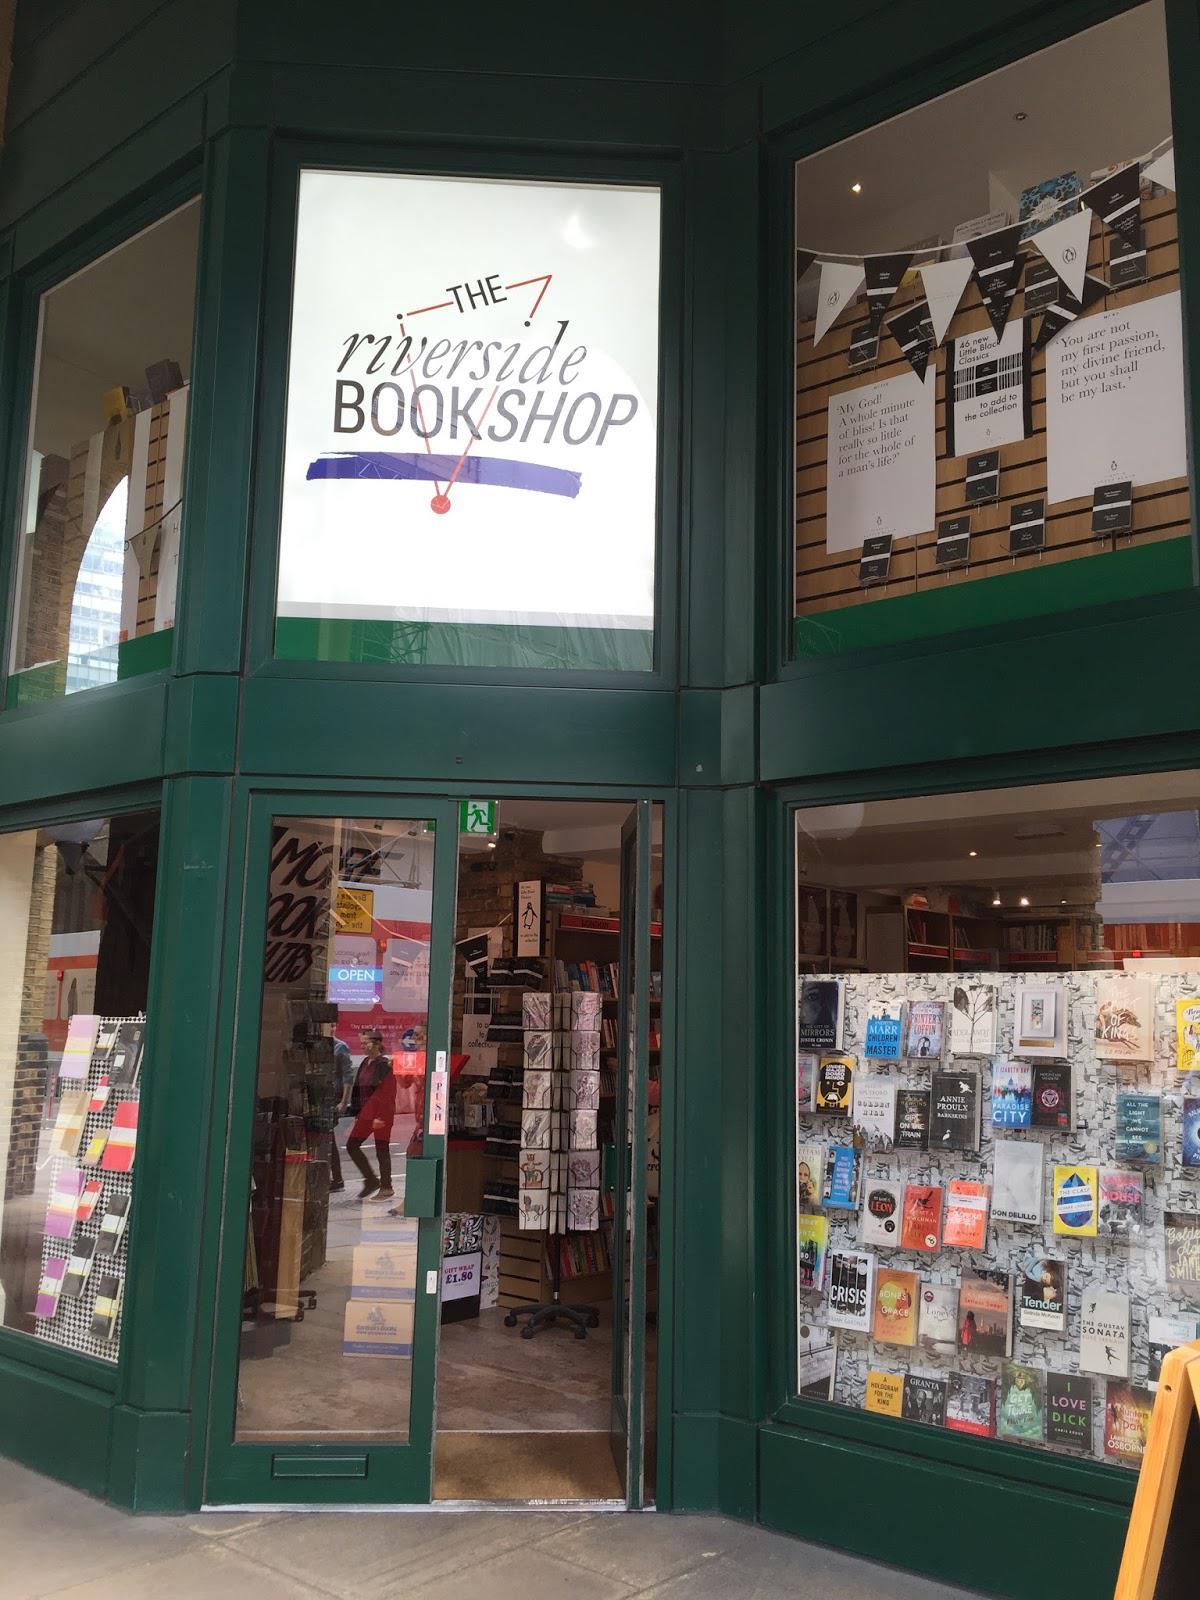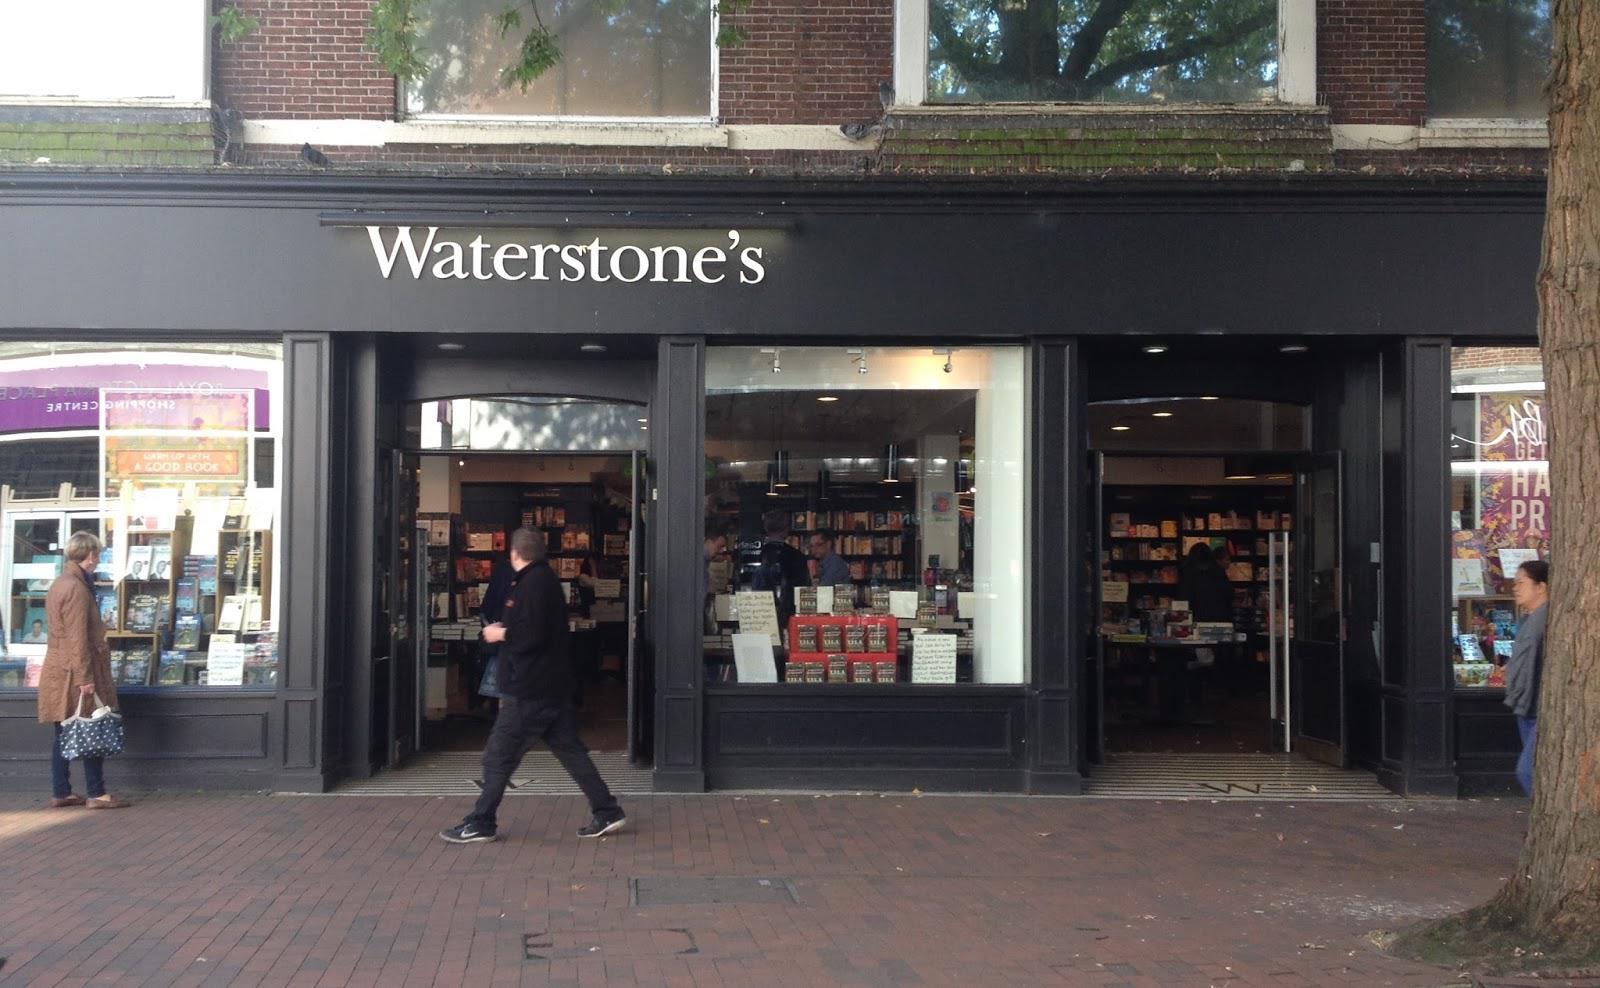The first image is the image on the left, the second image is the image on the right. Analyze the images presented: Is the assertion "A large arch shape is in the center of the left image, surrounded by other window shapes." valid? Answer yes or no. No. The first image is the image on the left, the second image is the image on the right. Examine the images to the left and right. Is the description "There are people visible, walking right outside of the building." accurate? Answer yes or no. Yes. 